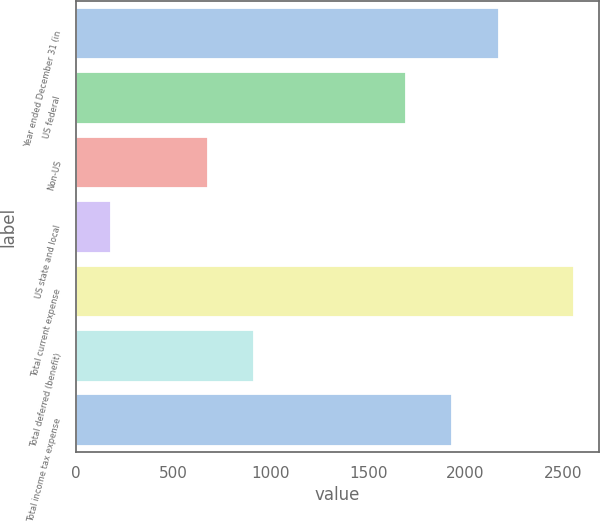Convert chart. <chart><loc_0><loc_0><loc_500><loc_500><bar_chart><fcel>Year ended December 31 (in<fcel>US federal<fcel>Non-US<fcel>US state and local<fcel>Total current expense<fcel>Total deferred (benefit)<fcel>Total income tax expense<nl><fcel>2169.8<fcel>1695<fcel>679<fcel>181<fcel>2555<fcel>916.4<fcel>1932.4<nl></chart> 